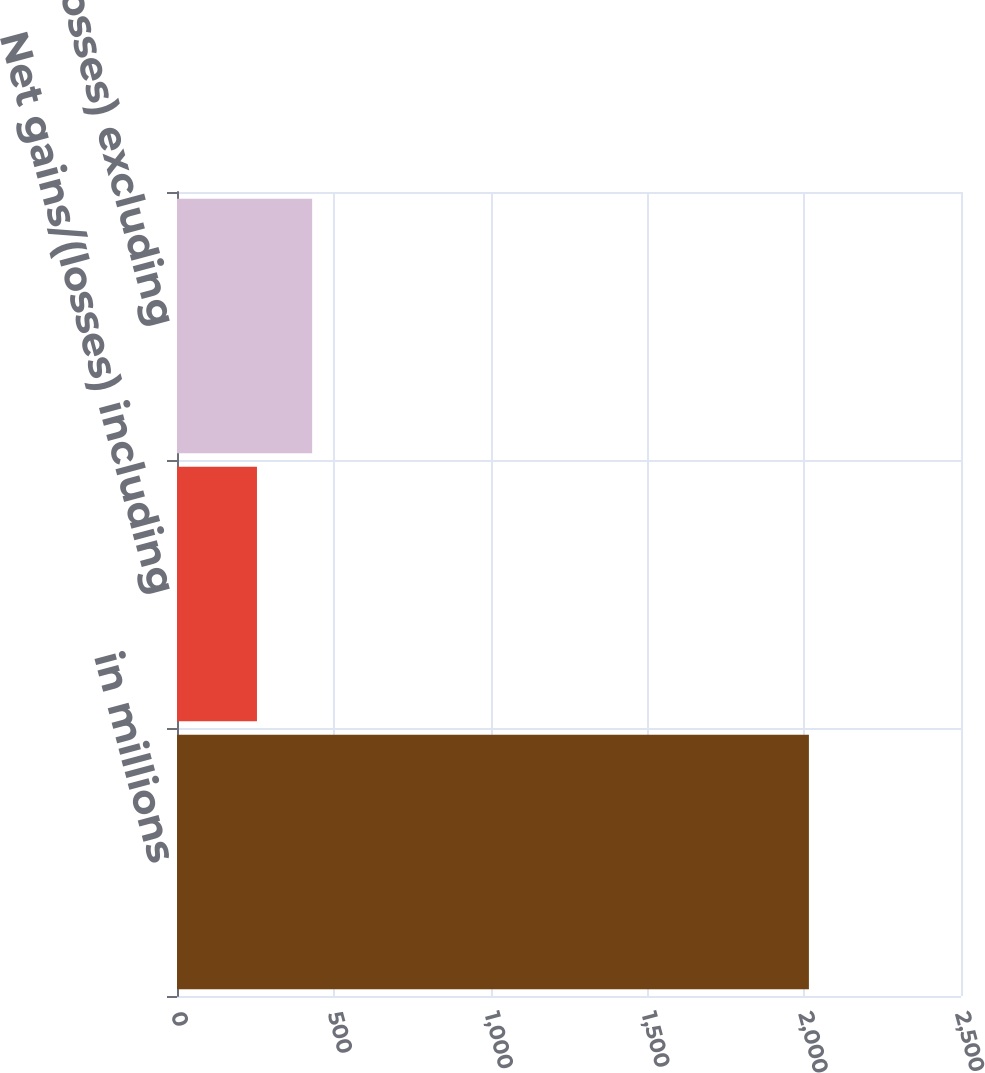<chart> <loc_0><loc_0><loc_500><loc_500><bar_chart><fcel>in millions<fcel>Net gains/(losses) including<fcel>Net gains/(losses) excluding<nl><fcel>2015<fcel>255<fcel>431<nl></chart> 